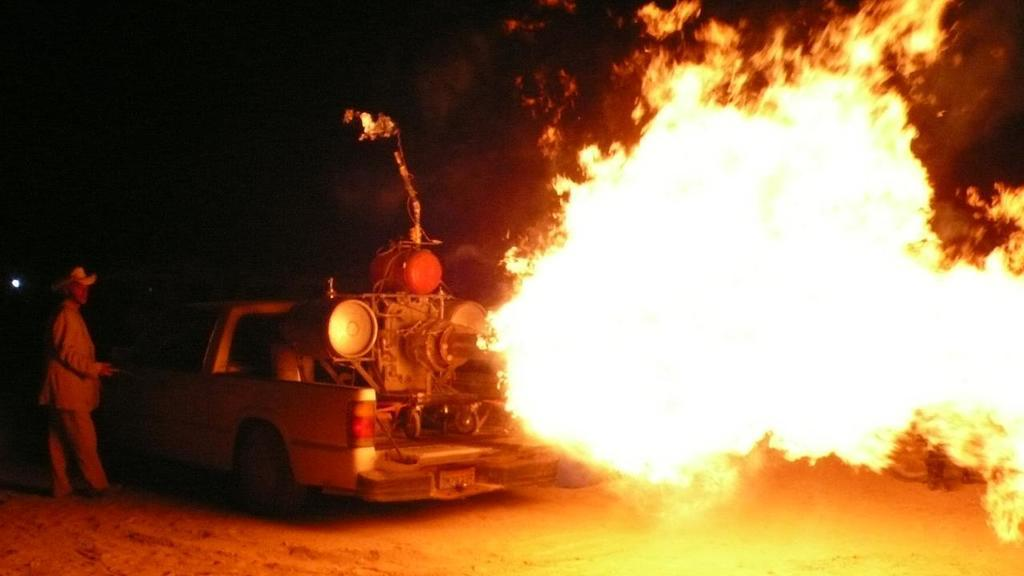What is the person in the image wearing? The person in the image is wearing a suit. What is the person's position in relation to the ground? The person is standing on the ground. What is the person standing near in the image? The person is near a vehicle. What is on the truck of the vehicle? There is an object on the truck of the vehicle, and it is emitting fire. What is the color of the background in the image? The background of the image is dark in color. How many oranges are being used to light the match in the image? There are no oranges or matches present in the image. Is there a bridge visible in the image? No, there is no bridge visible in the image. 